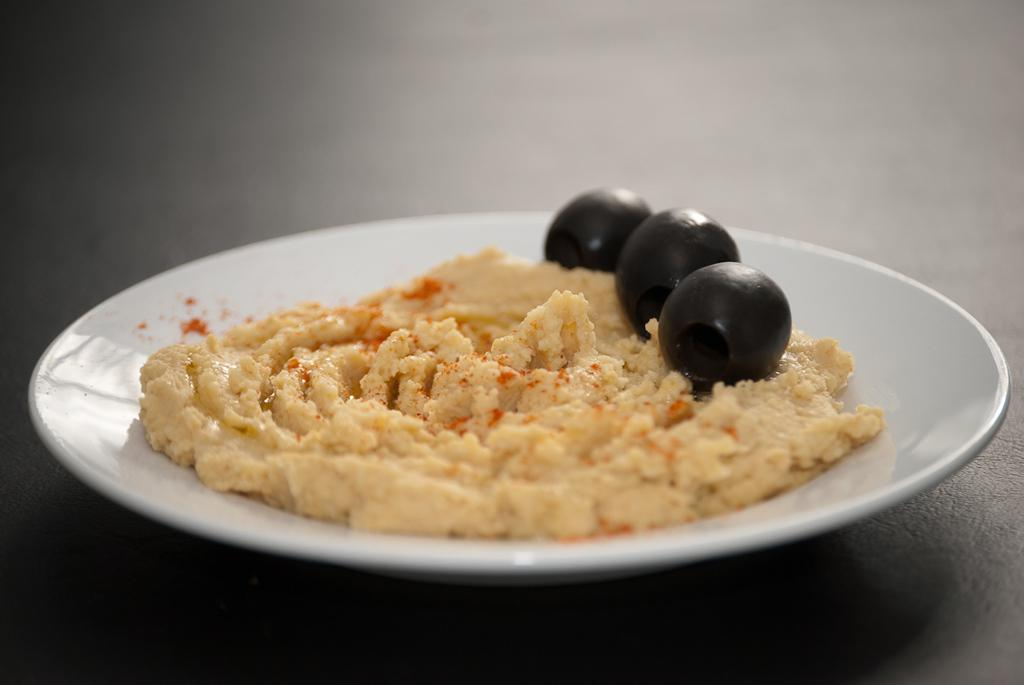What type of objects can be seen in the image? There are food items in the image. What is the color of the surface on which the food items are placed? The food items are on a white color palette. What other objects are present in the image besides the food items? There are black color balls in the image. What time does the clock show in the image? There are no clocks present in the image, so it is not possible to determine the time. 